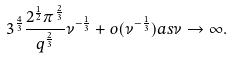Convert formula to latex. <formula><loc_0><loc_0><loc_500><loc_500>3 ^ { \frac { 4 } { 3 } } \frac { 2 ^ { \frac { 1 } { 2 } } \pi ^ { \frac { 2 } { 3 } } } { q ^ { \frac { 2 } { 3 } } } \nu ^ { - \frac { 1 } { 3 } } + o ( \nu ^ { - \frac { 1 } { 3 } } ) a s \nu \rightarrow \infty .</formula> 